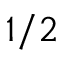Convert formula to latex. <formula><loc_0><loc_0><loc_500><loc_500>1 / 2</formula> 